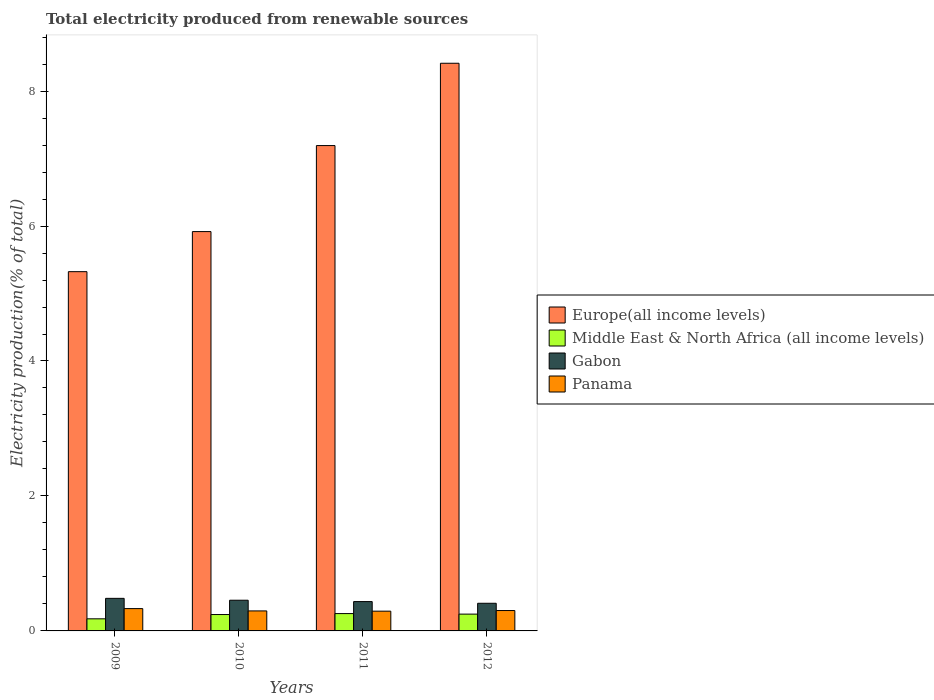How many groups of bars are there?
Offer a very short reply. 4. Are the number of bars on each tick of the X-axis equal?
Make the answer very short. Yes. How many bars are there on the 3rd tick from the left?
Ensure brevity in your answer.  4. How many bars are there on the 4th tick from the right?
Ensure brevity in your answer.  4. What is the total electricity produced in Europe(all income levels) in 2010?
Ensure brevity in your answer.  5.92. Across all years, what is the maximum total electricity produced in Middle East & North Africa (all income levels)?
Keep it short and to the point. 0.26. Across all years, what is the minimum total electricity produced in Middle East & North Africa (all income levels)?
Keep it short and to the point. 0.18. In which year was the total electricity produced in Middle East & North Africa (all income levels) minimum?
Your response must be concise. 2009. What is the total total electricity produced in Panama in the graph?
Your response must be concise. 1.22. What is the difference between the total electricity produced in Gabon in 2010 and that in 2012?
Offer a very short reply. 0.05. What is the difference between the total electricity produced in Panama in 2011 and the total electricity produced in Europe(all income levels) in 2009?
Provide a short and direct response. -5.03. What is the average total electricity produced in Gabon per year?
Provide a short and direct response. 0.45. In the year 2009, what is the difference between the total electricity produced in Europe(all income levels) and total electricity produced in Middle East & North Africa (all income levels)?
Your response must be concise. 5.14. What is the ratio of the total electricity produced in Panama in 2009 to that in 2012?
Give a very brief answer. 1.09. Is the total electricity produced in Gabon in 2009 less than that in 2012?
Your response must be concise. No. What is the difference between the highest and the second highest total electricity produced in Europe(all income levels)?
Ensure brevity in your answer.  1.22. What is the difference between the highest and the lowest total electricity produced in Gabon?
Your answer should be compact. 0.07. What does the 3rd bar from the left in 2010 represents?
Provide a succinct answer. Gabon. What does the 4th bar from the right in 2009 represents?
Offer a very short reply. Europe(all income levels). How many bars are there?
Ensure brevity in your answer.  16. What is the difference between two consecutive major ticks on the Y-axis?
Provide a succinct answer. 2. Are the values on the major ticks of Y-axis written in scientific E-notation?
Provide a succinct answer. No. How are the legend labels stacked?
Your response must be concise. Vertical. What is the title of the graph?
Your response must be concise. Total electricity produced from renewable sources. What is the label or title of the X-axis?
Provide a short and direct response. Years. What is the Electricity production(% of total) of Europe(all income levels) in 2009?
Give a very brief answer. 5.32. What is the Electricity production(% of total) of Middle East & North Africa (all income levels) in 2009?
Make the answer very short. 0.18. What is the Electricity production(% of total) of Gabon in 2009?
Keep it short and to the point. 0.48. What is the Electricity production(% of total) of Panama in 2009?
Make the answer very short. 0.33. What is the Electricity production(% of total) of Europe(all income levels) in 2010?
Your response must be concise. 5.92. What is the Electricity production(% of total) of Middle East & North Africa (all income levels) in 2010?
Give a very brief answer. 0.24. What is the Electricity production(% of total) in Gabon in 2010?
Your answer should be very brief. 0.45. What is the Electricity production(% of total) in Panama in 2010?
Your answer should be very brief. 0.3. What is the Electricity production(% of total) of Europe(all income levels) in 2011?
Your answer should be compact. 7.19. What is the Electricity production(% of total) in Middle East & North Africa (all income levels) in 2011?
Offer a terse response. 0.26. What is the Electricity production(% of total) of Gabon in 2011?
Make the answer very short. 0.43. What is the Electricity production(% of total) in Panama in 2011?
Your answer should be very brief. 0.29. What is the Electricity production(% of total) of Europe(all income levels) in 2012?
Offer a terse response. 8.41. What is the Electricity production(% of total) of Middle East & North Africa (all income levels) in 2012?
Your answer should be compact. 0.25. What is the Electricity production(% of total) in Gabon in 2012?
Provide a succinct answer. 0.41. What is the Electricity production(% of total) of Panama in 2012?
Make the answer very short. 0.3. Across all years, what is the maximum Electricity production(% of total) of Europe(all income levels)?
Make the answer very short. 8.41. Across all years, what is the maximum Electricity production(% of total) of Middle East & North Africa (all income levels)?
Give a very brief answer. 0.26. Across all years, what is the maximum Electricity production(% of total) of Gabon?
Make the answer very short. 0.48. Across all years, what is the maximum Electricity production(% of total) in Panama?
Your answer should be compact. 0.33. Across all years, what is the minimum Electricity production(% of total) in Europe(all income levels)?
Provide a succinct answer. 5.32. Across all years, what is the minimum Electricity production(% of total) in Middle East & North Africa (all income levels)?
Your response must be concise. 0.18. Across all years, what is the minimum Electricity production(% of total) in Gabon?
Provide a short and direct response. 0.41. Across all years, what is the minimum Electricity production(% of total) of Panama?
Keep it short and to the point. 0.29. What is the total Electricity production(% of total) in Europe(all income levels) in the graph?
Offer a very short reply. 26.85. What is the total Electricity production(% of total) in Middle East & North Africa (all income levels) in the graph?
Give a very brief answer. 0.93. What is the total Electricity production(% of total) of Gabon in the graph?
Offer a terse response. 1.78. What is the total Electricity production(% of total) of Panama in the graph?
Your answer should be very brief. 1.22. What is the difference between the Electricity production(% of total) of Europe(all income levels) in 2009 and that in 2010?
Give a very brief answer. -0.59. What is the difference between the Electricity production(% of total) in Middle East & North Africa (all income levels) in 2009 and that in 2010?
Provide a succinct answer. -0.06. What is the difference between the Electricity production(% of total) of Gabon in 2009 and that in 2010?
Your answer should be compact. 0.03. What is the difference between the Electricity production(% of total) of Panama in 2009 and that in 2010?
Your answer should be very brief. 0.03. What is the difference between the Electricity production(% of total) of Europe(all income levels) in 2009 and that in 2011?
Keep it short and to the point. -1.87. What is the difference between the Electricity production(% of total) in Middle East & North Africa (all income levels) in 2009 and that in 2011?
Ensure brevity in your answer.  -0.08. What is the difference between the Electricity production(% of total) of Gabon in 2009 and that in 2011?
Offer a terse response. 0.05. What is the difference between the Electricity production(% of total) in Panama in 2009 and that in 2011?
Make the answer very short. 0.04. What is the difference between the Electricity production(% of total) of Europe(all income levels) in 2009 and that in 2012?
Give a very brief answer. -3.09. What is the difference between the Electricity production(% of total) of Middle East & North Africa (all income levels) in 2009 and that in 2012?
Offer a very short reply. -0.07. What is the difference between the Electricity production(% of total) of Gabon in 2009 and that in 2012?
Make the answer very short. 0.07. What is the difference between the Electricity production(% of total) of Panama in 2009 and that in 2012?
Give a very brief answer. 0.03. What is the difference between the Electricity production(% of total) of Europe(all income levels) in 2010 and that in 2011?
Make the answer very short. -1.27. What is the difference between the Electricity production(% of total) in Middle East & North Africa (all income levels) in 2010 and that in 2011?
Your response must be concise. -0.01. What is the difference between the Electricity production(% of total) of Panama in 2010 and that in 2011?
Offer a terse response. 0. What is the difference between the Electricity production(% of total) in Europe(all income levels) in 2010 and that in 2012?
Your response must be concise. -2.49. What is the difference between the Electricity production(% of total) of Middle East & North Africa (all income levels) in 2010 and that in 2012?
Ensure brevity in your answer.  -0.01. What is the difference between the Electricity production(% of total) in Gabon in 2010 and that in 2012?
Provide a short and direct response. 0.05. What is the difference between the Electricity production(% of total) in Panama in 2010 and that in 2012?
Provide a short and direct response. -0.01. What is the difference between the Electricity production(% of total) of Europe(all income levels) in 2011 and that in 2012?
Offer a very short reply. -1.22. What is the difference between the Electricity production(% of total) in Middle East & North Africa (all income levels) in 2011 and that in 2012?
Your answer should be very brief. 0.01. What is the difference between the Electricity production(% of total) in Gabon in 2011 and that in 2012?
Offer a terse response. 0.03. What is the difference between the Electricity production(% of total) in Panama in 2011 and that in 2012?
Your response must be concise. -0.01. What is the difference between the Electricity production(% of total) in Europe(all income levels) in 2009 and the Electricity production(% of total) in Middle East & North Africa (all income levels) in 2010?
Make the answer very short. 5.08. What is the difference between the Electricity production(% of total) of Europe(all income levels) in 2009 and the Electricity production(% of total) of Gabon in 2010?
Offer a terse response. 4.87. What is the difference between the Electricity production(% of total) of Europe(all income levels) in 2009 and the Electricity production(% of total) of Panama in 2010?
Give a very brief answer. 5.03. What is the difference between the Electricity production(% of total) in Middle East & North Africa (all income levels) in 2009 and the Electricity production(% of total) in Gabon in 2010?
Ensure brevity in your answer.  -0.28. What is the difference between the Electricity production(% of total) of Middle East & North Africa (all income levels) in 2009 and the Electricity production(% of total) of Panama in 2010?
Keep it short and to the point. -0.12. What is the difference between the Electricity production(% of total) of Gabon in 2009 and the Electricity production(% of total) of Panama in 2010?
Provide a succinct answer. 0.19. What is the difference between the Electricity production(% of total) of Europe(all income levels) in 2009 and the Electricity production(% of total) of Middle East & North Africa (all income levels) in 2011?
Your response must be concise. 5.07. What is the difference between the Electricity production(% of total) in Europe(all income levels) in 2009 and the Electricity production(% of total) in Gabon in 2011?
Give a very brief answer. 4.89. What is the difference between the Electricity production(% of total) of Europe(all income levels) in 2009 and the Electricity production(% of total) of Panama in 2011?
Your answer should be very brief. 5.03. What is the difference between the Electricity production(% of total) of Middle East & North Africa (all income levels) in 2009 and the Electricity production(% of total) of Gabon in 2011?
Keep it short and to the point. -0.26. What is the difference between the Electricity production(% of total) of Middle East & North Africa (all income levels) in 2009 and the Electricity production(% of total) of Panama in 2011?
Your response must be concise. -0.11. What is the difference between the Electricity production(% of total) in Gabon in 2009 and the Electricity production(% of total) in Panama in 2011?
Offer a very short reply. 0.19. What is the difference between the Electricity production(% of total) of Europe(all income levels) in 2009 and the Electricity production(% of total) of Middle East & North Africa (all income levels) in 2012?
Offer a very short reply. 5.08. What is the difference between the Electricity production(% of total) of Europe(all income levels) in 2009 and the Electricity production(% of total) of Gabon in 2012?
Ensure brevity in your answer.  4.91. What is the difference between the Electricity production(% of total) in Europe(all income levels) in 2009 and the Electricity production(% of total) in Panama in 2012?
Provide a succinct answer. 5.02. What is the difference between the Electricity production(% of total) of Middle East & North Africa (all income levels) in 2009 and the Electricity production(% of total) of Gabon in 2012?
Offer a terse response. -0.23. What is the difference between the Electricity production(% of total) in Middle East & North Africa (all income levels) in 2009 and the Electricity production(% of total) in Panama in 2012?
Offer a very short reply. -0.12. What is the difference between the Electricity production(% of total) in Gabon in 2009 and the Electricity production(% of total) in Panama in 2012?
Your answer should be compact. 0.18. What is the difference between the Electricity production(% of total) in Europe(all income levels) in 2010 and the Electricity production(% of total) in Middle East & North Africa (all income levels) in 2011?
Give a very brief answer. 5.66. What is the difference between the Electricity production(% of total) of Europe(all income levels) in 2010 and the Electricity production(% of total) of Gabon in 2011?
Provide a short and direct response. 5.48. What is the difference between the Electricity production(% of total) of Europe(all income levels) in 2010 and the Electricity production(% of total) of Panama in 2011?
Provide a succinct answer. 5.62. What is the difference between the Electricity production(% of total) of Middle East & North Africa (all income levels) in 2010 and the Electricity production(% of total) of Gabon in 2011?
Keep it short and to the point. -0.19. What is the difference between the Electricity production(% of total) of Gabon in 2010 and the Electricity production(% of total) of Panama in 2011?
Keep it short and to the point. 0.16. What is the difference between the Electricity production(% of total) of Europe(all income levels) in 2010 and the Electricity production(% of total) of Middle East & North Africa (all income levels) in 2012?
Your response must be concise. 5.67. What is the difference between the Electricity production(% of total) in Europe(all income levels) in 2010 and the Electricity production(% of total) in Gabon in 2012?
Ensure brevity in your answer.  5.51. What is the difference between the Electricity production(% of total) in Europe(all income levels) in 2010 and the Electricity production(% of total) in Panama in 2012?
Provide a short and direct response. 5.62. What is the difference between the Electricity production(% of total) in Middle East & North Africa (all income levels) in 2010 and the Electricity production(% of total) in Gabon in 2012?
Provide a succinct answer. -0.17. What is the difference between the Electricity production(% of total) in Middle East & North Africa (all income levels) in 2010 and the Electricity production(% of total) in Panama in 2012?
Offer a terse response. -0.06. What is the difference between the Electricity production(% of total) of Gabon in 2010 and the Electricity production(% of total) of Panama in 2012?
Provide a short and direct response. 0.15. What is the difference between the Electricity production(% of total) of Europe(all income levels) in 2011 and the Electricity production(% of total) of Middle East & North Africa (all income levels) in 2012?
Your answer should be very brief. 6.94. What is the difference between the Electricity production(% of total) in Europe(all income levels) in 2011 and the Electricity production(% of total) in Gabon in 2012?
Provide a succinct answer. 6.78. What is the difference between the Electricity production(% of total) of Europe(all income levels) in 2011 and the Electricity production(% of total) of Panama in 2012?
Give a very brief answer. 6.89. What is the difference between the Electricity production(% of total) of Middle East & North Africa (all income levels) in 2011 and the Electricity production(% of total) of Gabon in 2012?
Your response must be concise. -0.15. What is the difference between the Electricity production(% of total) of Middle East & North Africa (all income levels) in 2011 and the Electricity production(% of total) of Panama in 2012?
Ensure brevity in your answer.  -0.05. What is the difference between the Electricity production(% of total) in Gabon in 2011 and the Electricity production(% of total) in Panama in 2012?
Give a very brief answer. 0.13. What is the average Electricity production(% of total) in Europe(all income levels) per year?
Ensure brevity in your answer.  6.71. What is the average Electricity production(% of total) in Middle East & North Africa (all income levels) per year?
Make the answer very short. 0.23. What is the average Electricity production(% of total) in Gabon per year?
Keep it short and to the point. 0.45. What is the average Electricity production(% of total) of Panama per year?
Provide a short and direct response. 0.31. In the year 2009, what is the difference between the Electricity production(% of total) of Europe(all income levels) and Electricity production(% of total) of Middle East & North Africa (all income levels)?
Make the answer very short. 5.14. In the year 2009, what is the difference between the Electricity production(% of total) of Europe(all income levels) and Electricity production(% of total) of Gabon?
Ensure brevity in your answer.  4.84. In the year 2009, what is the difference between the Electricity production(% of total) in Europe(all income levels) and Electricity production(% of total) in Panama?
Offer a terse response. 4.99. In the year 2009, what is the difference between the Electricity production(% of total) in Middle East & North Africa (all income levels) and Electricity production(% of total) in Gabon?
Your answer should be very brief. -0.3. In the year 2009, what is the difference between the Electricity production(% of total) of Middle East & North Africa (all income levels) and Electricity production(% of total) of Panama?
Your answer should be very brief. -0.15. In the year 2009, what is the difference between the Electricity production(% of total) in Gabon and Electricity production(% of total) in Panama?
Ensure brevity in your answer.  0.15. In the year 2010, what is the difference between the Electricity production(% of total) in Europe(all income levels) and Electricity production(% of total) in Middle East & North Africa (all income levels)?
Provide a short and direct response. 5.67. In the year 2010, what is the difference between the Electricity production(% of total) in Europe(all income levels) and Electricity production(% of total) in Gabon?
Give a very brief answer. 5.46. In the year 2010, what is the difference between the Electricity production(% of total) in Europe(all income levels) and Electricity production(% of total) in Panama?
Your response must be concise. 5.62. In the year 2010, what is the difference between the Electricity production(% of total) of Middle East & North Africa (all income levels) and Electricity production(% of total) of Gabon?
Offer a terse response. -0.21. In the year 2010, what is the difference between the Electricity production(% of total) of Middle East & North Africa (all income levels) and Electricity production(% of total) of Panama?
Keep it short and to the point. -0.05. In the year 2010, what is the difference between the Electricity production(% of total) in Gabon and Electricity production(% of total) in Panama?
Your answer should be very brief. 0.16. In the year 2011, what is the difference between the Electricity production(% of total) in Europe(all income levels) and Electricity production(% of total) in Middle East & North Africa (all income levels)?
Keep it short and to the point. 6.94. In the year 2011, what is the difference between the Electricity production(% of total) in Europe(all income levels) and Electricity production(% of total) in Gabon?
Provide a short and direct response. 6.76. In the year 2011, what is the difference between the Electricity production(% of total) in Europe(all income levels) and Electricity production(% of total) in Panama?
Ensure brevity in your answer.  6.9. In the year 2011, what is the difference between the Electricity production(% of total) of Middle East & North Africa (all income levels) and Electricity production(% of total) of Gabon?
Provide a short and direct response. -0.18. In the year 2011, what is the difference between the Electricity production(% of total) in Middle East & North Africa (all income levels) and Electricity production(% of total) in Panama?
Offer a very short reply. -0.04. In the year 2011, what is the difference between the Electricity production(% of total) in Gabon and Electricity production(% of total) in Panama?
Keep it short and to the point. 0.14. In the year 2012, what is the difference between the Electricity production(% of total) of Europe(all income levels) and Electricity production(% of total) of Middle East & North Africa (all income levels)?
Make the answer very short. 8.16. In the year 2012, what is the difference between the Electricity production(% of total) in Europe(all income levels) and Electricity production(% of total) in Gabon?
Provide a short and direct response. 8. In the year 2012, what is the difference between the Electricity production(% of total) of Europe(all income levels) and Electricity production(% of total) of Panama?
Provide a succinct answer. 8.11. In the year 2012, what is the difference between the Electricity production(% of total) of Middle East & North Africa (all income levels) and Electricity production(% of total) of Gabon?
Offer a very short reply. -0.16. In the year 2012, what is the difference between the Electricity production(% of total) of Middle East & North Africa (all income levels) and Electricity production(% of total) of Panama?
Your answer should be very brief. -0.05. In the year 2012, what is the difference between the Electricity production(% of total) in Gabon and Electricity production(% of total) in Panama?
Provide a succinct answer. 0.11. What is the ratio of the Electricity production(% of total) of Europe(all income levels) in 2009 to that in 2010?
Your response must be concise. 0.9. What is the ratio of the Electricity production(% of total) of Middle East & North Africa (all income levels) in 2009 to that in 2010?
Your answer should be compact. 0.74. What is the ratio of the Electricity production(% of total) in Gabon in 2009 to that in 2010?
Provide a short and direct response. 1.06. What is the ratio of the Electricity production(% of total) of Panama in 2009 to that in 2010?
Offer a very short reply. 1.12. What is the ratio of the Electricity production(% of total) in Europe(all income levels) in 2009 to that in 2011?
Your answer should be compact. 0.74. What is the ratio of the Electricity production(% of total) in Middle East & North Africa (all income levels) in 2009 to that in 2011?
Your answer should be compact. 0.7. What is the ratio of the Electricity production(% of total) of Gabon in 2009 to that in 2011?
Keep it short and to the point. 1.11. What is the ratio of the Electricity production(% of total) of Panama in 2009 to that in 2011?
Provide a succinct answer. 1.13. What is the ratio of the Electricity production(% of total) of Europe(all income levels) in 2009 to that in 2012?
Ensure brevity in your answer.  0.63. What is the ratio of the Electricity production(% of total) in Middle East & North Africa (all income levels) in 2009 to that in 2012?
Make the answer very short. 0.72. What is the ratio of the Electricity production(% of total) in Gabon in 2009 to that in 2012?
Offer a terse response. 1.18. What is the ratio of the Electricity production(% of total) of Panama in 2009 to that in 2012?
Your answer should be compact. 1.09. What is the ratio of the Electricity production(% of total) in Europe(all income levels) in 2010 to that in 2011?
Your answer should be very brief. 0.82. What is the ratio of the Electricity production(% of total) in Middle East & North Africa (all income levels) in 2010 to that in 2011?
Provide a succinct answer. 0.94. What is the ratio of the Electricity production(% of total) in Gabon in 2010 to that in 2011?
Your answer should be compact. 1.05. What is the ratio of the Electricity production(% of total) of Europe(all income levels) in 2010 to that in 2012?
Your response must be concise. 0.7. What is the ratio of the Electricity production(% of total) in Middle East & North Africa (all income levels) in 2010 to that in 2012?
Provide a short and direct response. 0.98. What is the ratio of the Electricity production(% of total) in Gabon in 2010 to that in 2012?
Ensure brevity in your answer.  1.11. What is the ratio of the Electricity production(% of total) of Panama in 2010 to that in 2012?
Provide a short and direct response. 0.98. What is the ratio of the Electricity production(% of total) in Europe(all income levels) in 2011 to that in 2012?
Offer a very short reply. 0.85. What is the ratio of the Electricity production(% of total) of Middle East & North Africa (all income levels) in 2011 to that in 2012?
Offer a terse response. 1.03. What is the ratio of the Electricity production(% of total) of Gabon in 2011 to that in 2012?
Ensure brevity in your answer.  1.06. What is the ratio of the Electricity production(% of total) in Panama in 2011 to that in 2012?
Keep it short and to the point. 0.97. What is the difference between the highest and the second highest Electricity production(% of total) in Europe(all income levels)?
Your answer should be very brief. 1.22. What is the difference between the highest and the second highest Electricity production(% of total) in Middle East & North Africa (all income levels)?
Provide a succinct answer. 0.01. What is the difference between the highest and the second highest Electricity production(% of total) of Gabon?
Give a very brief answer. 0.03. What is the difference between the highest and the second highest Electricity production(% of total) in Panama?
Your answer should be compact. 0.03. What is the difference between the highest and the lowest Electricity production(% of total) in Europe(all income levels)?
Provide a succinct answer. 3.09. What is the difference between the highest and the lowest Electricity production(% of total) of Middle East & North Africa (all income levels)?
Your answer should be very brief. 0.08. What is the difference between the highest and the lowest Electricity production(% of total) in Gabon?
Your answer should be very brief. 0.07. What is the difference between the highest and the lowest Electricity production(% of total) in Panama?
Your response must be concise. 0.04. 